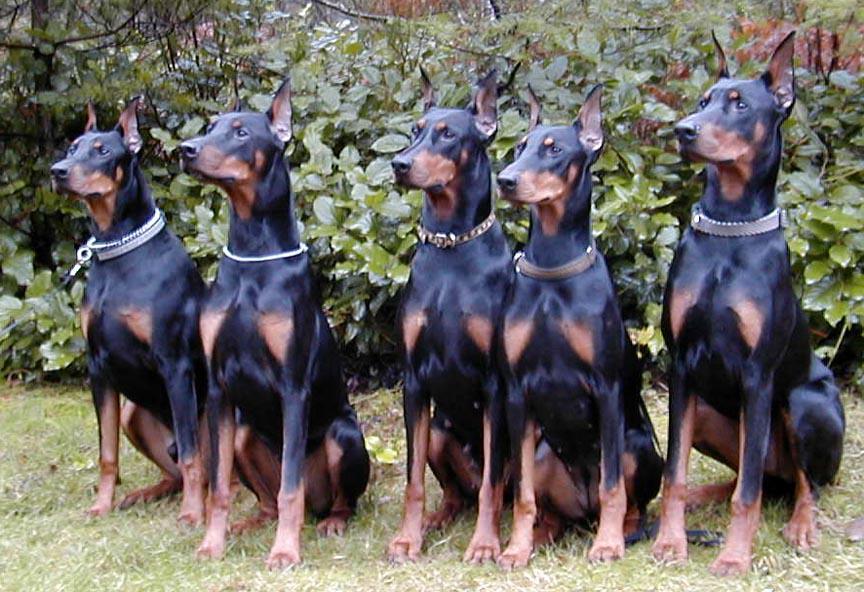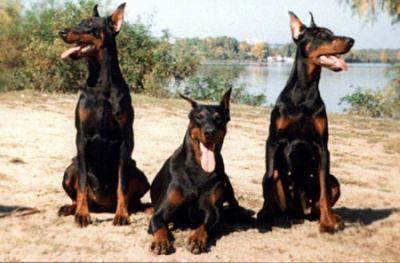The first image is the image on the left, the second image is the image on the right. Assess this claim about the two images: "Every picture has 3 dogs in it.". Correct or not? Answer yes or no. No. The first image is the image on the left, the second image is the image on the right. Analyze the images presented: Is the assertion "There are three dogs exactly in each image." valid? Answer yes or no. No. 